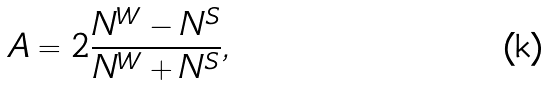<formula> <loc_0><loc_0><loc_500><loc_500>A = 2 \frac { N ^ { W } - N ^ { S } } { N ^ { W } + N ^ { S } } ,</formula> 